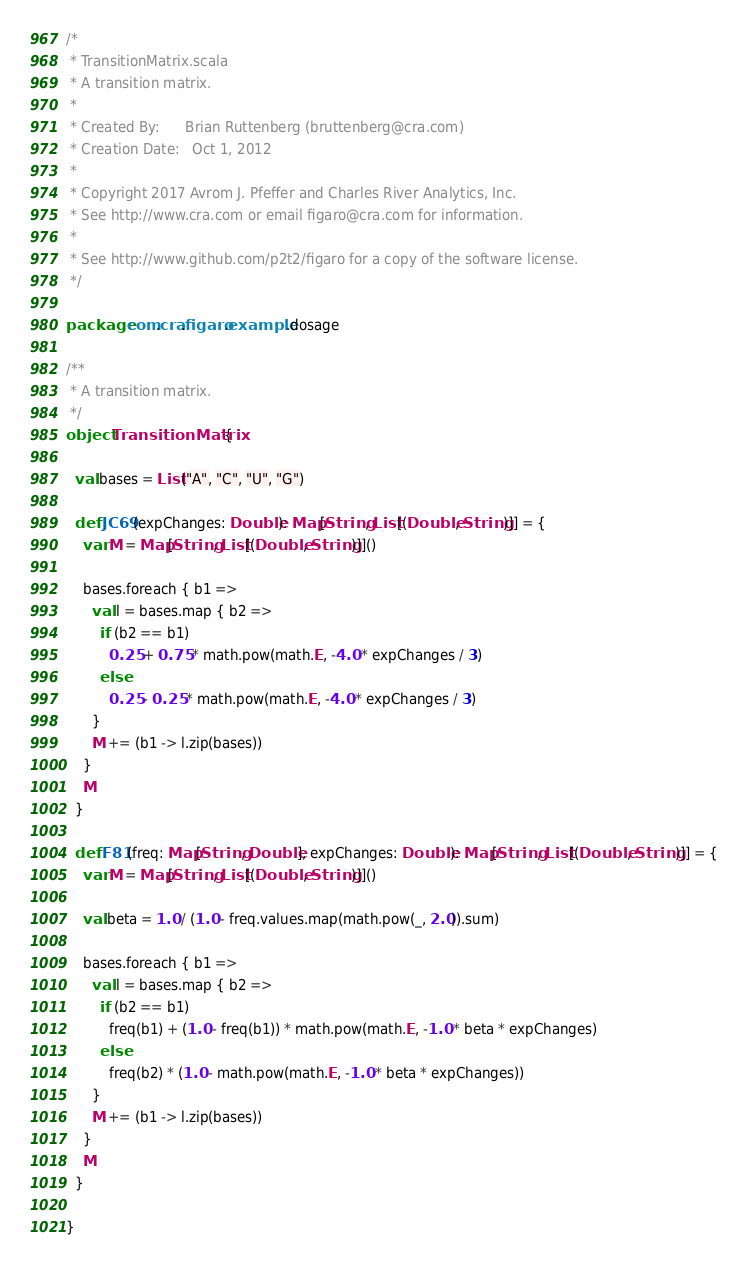<code> <loc_0><loc_0><loc_500><loc_500><_Scala_>/*
 * TransitionMatrix.scala
 * A transition matrix.
 * 
 * Created By:      Brian Ruttenberg (bruttenberg@cra.com)
 * Creation Date:   Oct 1, 2012
 * 
 * Copyright 2017 Avrom J. Pfeffer and Charles River Analytics, Inc.
 * See http://www.cra.com or email figaro@cra.com for information.
 * 
 * See http://www.github.com/p2t2/figaro for a copy of the software license.
 */

package com.cra.figaro.example.dosage

/**
 * A transition matrix.
 */
object TransitionMatrix {

  val bases = List("A", "C", "U", "G")

  def JC69(expChanges: Double): Map[String, List[(Double, String)]] = {
    var M = Map[String, List[(Double, String)]]()

    bases.foreach { b1 =>
      val l = bases.map { b2 =>
        if (b2 == b1)
          0.25 + 0.75 * math.pow(math.E, -4.0 * expChanges / 3)
        else
          0.25 - 0.25 * math.pow(math.E, -4.0 * expChanges / 3)
      }
      M += (b1 -> l.zip(bases))
    }
    M
  }

  def F81(freq: Map[String, Double], expChanges: Double): Map[String, List[(Double, String)]] = {
    var M = Map[String, List[(Double, String)]]()

    val beta = 1.0 / (1.0 - freq.values.map(math.pow(_, 2.0)).sum)

    bases.foreach { b1 =>
      val l = bases.map { b2 =>
        if (b2 == b1)
          freq(b1) + (1.0 - freq(b1)) * math.pow(math.E, -1.0 * beta * expChanges)
        else
          freq(b2) * (1.0 - math.pow(math.E, -1.0 * beta * expChanges))
      }
      M += (b1 -> l.zip(bases))
    }
    M
  }

}
</code> 